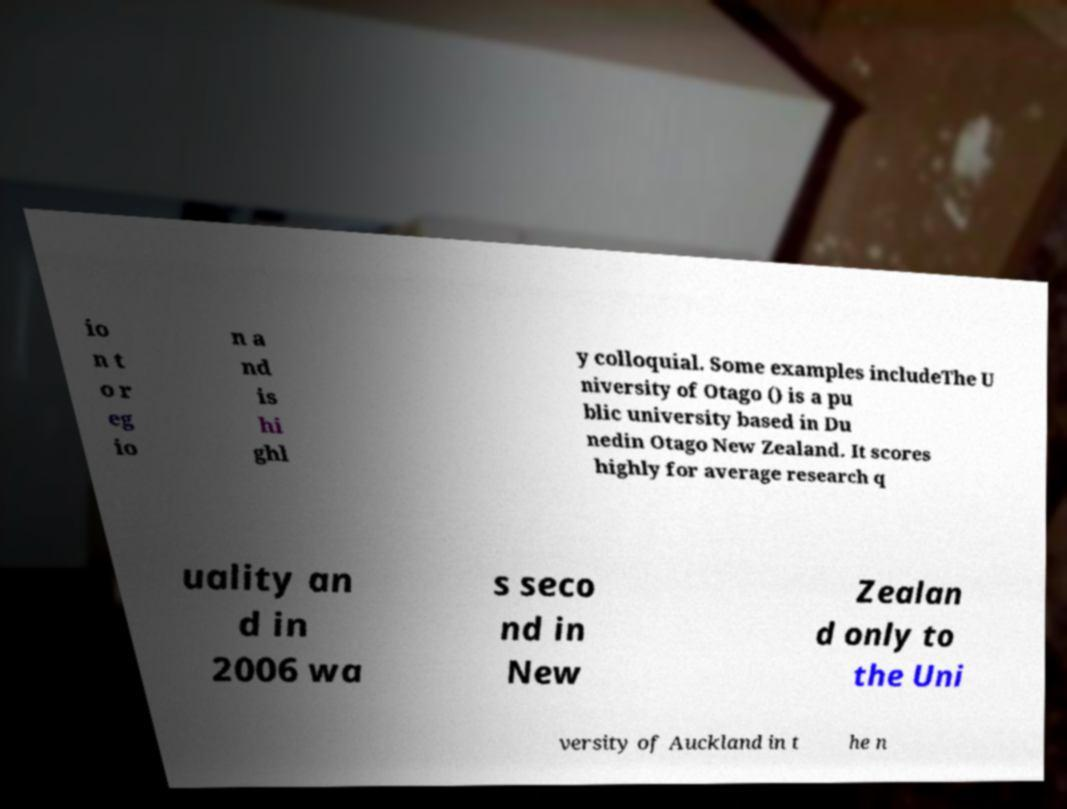Could you assist in decoding the text presented in this image and type it out clearly? io n t o r eg io n a nd is hi ghl y colloquial. Some examples includeThe U niversity of Otago () is a pu blic university based in Du nedin Otago New Zealand. It scores highly for average research q uality an d in 2006 wa s seco nd in New Zealan d only to the Uni versity of Auckland in t he n 